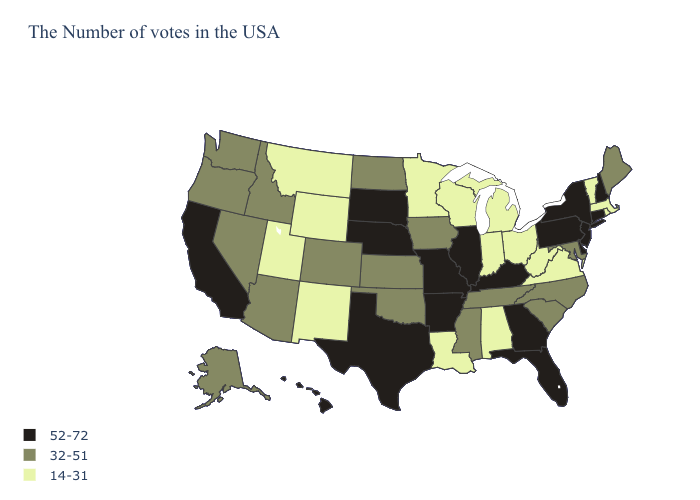What is the lowest value in states that border Washington?
Quick response, please. 32-51. Name the states that have a value in the range 32-51?
Answer briefly. Maine, Maryland, North Carolina, South Carolina, Tennessee, Mississippi, Iowa, Kansas, Oklahoma, North Dakota, Colorado, Arizona, Idaho, Nevada, Washington, Oregon, Alaska. Does the map have missing data?
Concise answer only. No. Among the states that border Nebraska , does Colorado have the lowest value?
Answer briefly. No. What is the value of Massachusetts?
Write a very short answer. 14-31. What is the value of Delaware?
Answer briefly. 52-72. Does the map have missing data?
Answer briefly. No. Which states have the highest value in the USA?
Answer briefly. New Hampshire, Connecticut, New York, New Jersey, Delaware, Pennsylvania, Florida, Georgia, Kentucky, Illinois, Missouri, Arkansas, Nebraska, Texas, South Dakota, California, Hawaii. What is the value of Arizona?
Concise answer only. 32-51. What is the value of Alabama?
Quick response, please. 14-31. Does Delaware have the highest value in the USA?
Concise answer only. Yes. Does Rhode Island have the highest value in the Northeast?
Short answer required. No. Does New Hampshire have the highest value in the Northeast?
Short answer required. Yes. What is the highest value in states that border New Mexico?
Give a very brief answer. 52-72. 